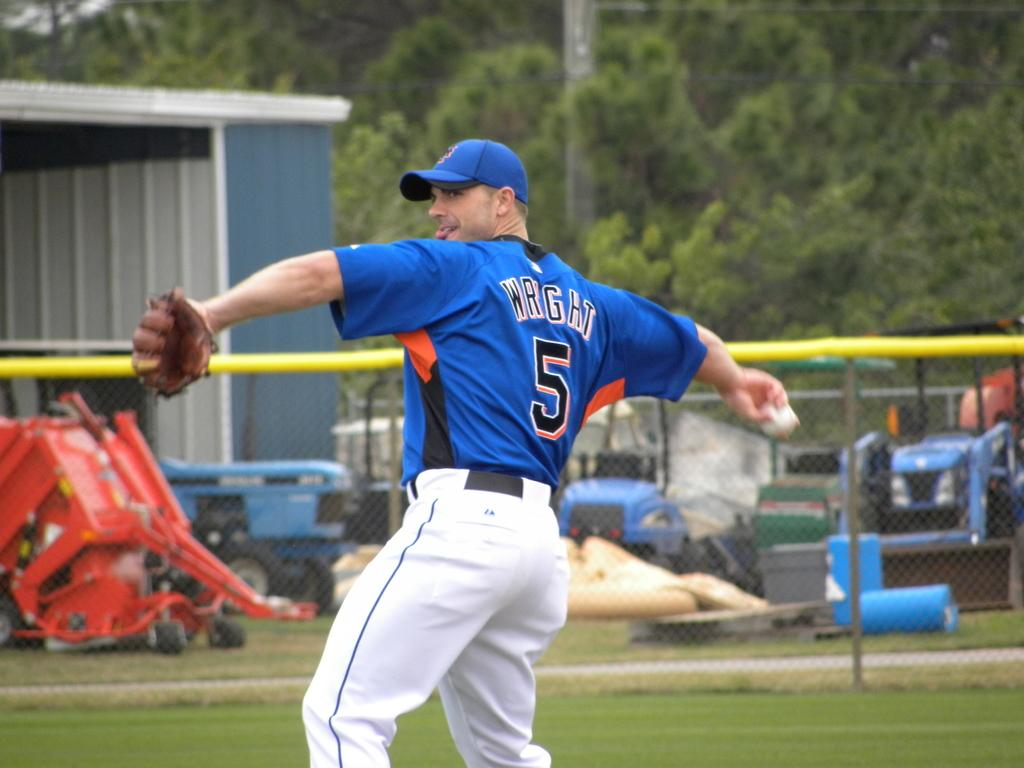<image>
Relay a brief, clear account of the picture shown. A picture of a baseball player in a blue jersey named Wright. 